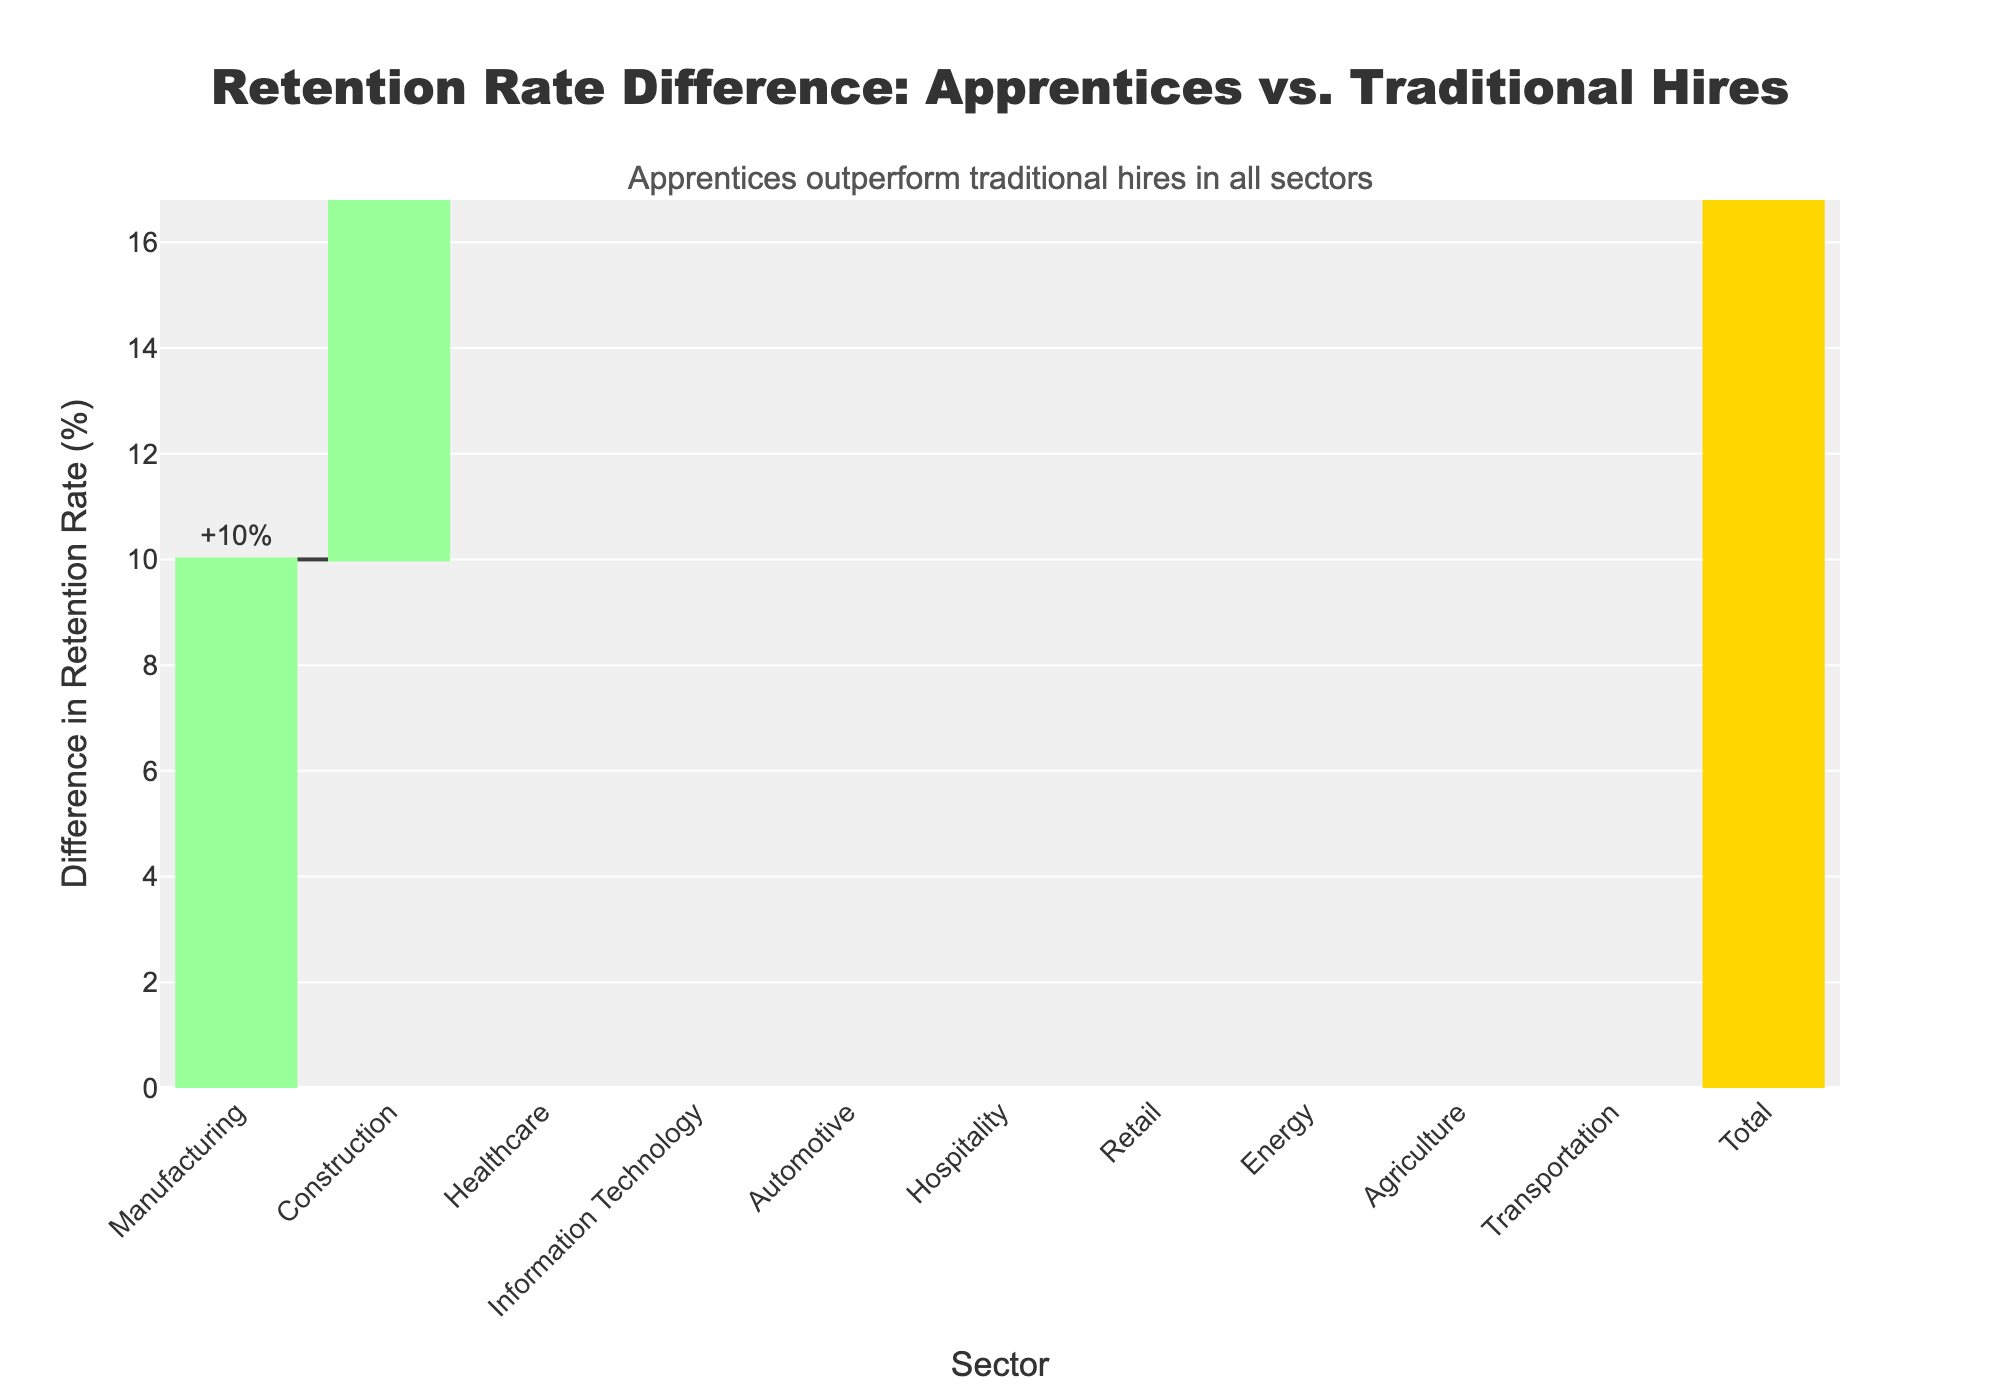What is the title of the waterfall chart? The title is displayed at the top of the chart and reads "Retention Rate Difference: Apprentices vs. Traditional Hires".
Answer: "Retention Rate Difference: Apprentices vs. Traditional Hires" How many sectors are compared in the chart? The chart lists each sector along the x-axis, and there are 10 distinct sectors labeled: Manufacturing, Construction, Healthcare, Information Technology, Automotive, Hospitality, Retail, Energy, Agriculture, and Transportation.
Answer: 10 Which sector has the highest retention rate difference? The highest retention rate difference is identified by looking at the longest bar, which corresponds to the Retail sector with a difference of +14%.
Answer: Retail What is the total retention rate difference across all sectors? The waterfall chart includes a "Total" bar at the end, representing the sum of the differences from all sectors. The total retention rate difference is +114%.
Answer: +114% Which sectors have an equal difference in retention rates? Identifying sectors with identical retention rate differences involves comparing the heights of the bars. Both the Automotive and Construction sectors have a difference of +12%.
Answer: Automotive and Construction What is the difference in retention rates for the Healthcare sector? The Healthcare sector is labeled along the x-axis, and its corresponding bar shows a difference of +8%.
Answer: +8% How does the retention rate difference in the Energy sector compare to Information Technology? The bars for both sectors are compared: the Energy sector has a difference of +8%, and the Information Technology sector has +11%. Since +11% is greater than +8%, Information Technology has a higher difference.
Answer: Information Technology has a higher difference Which sector shows a retention rate difference of less than 10%? We look for bars whose text labels indicate less than +10%. The sectors with a retention rate difference below +10% are Healthcare (+8%) and Energy (+8%).
Answer: Healthcare and Energy What is the increase in retention rates for apprentices in the Transportation sector? For the Transportation sector, the bar shows a difference of +13%, which means the retention rate for apprentices is 13% higher compared to traditional hires.
Answer: +13% Does the Agriculture sector have a higher or lower retention rate difference compared to the Manufacturing sector? Comparing the two sectors, the Agriculture sector has a difference of +12%, while the Manufacturing sector has +10%. Since +12% is higher than +10%, Agriculture has a higher difference.
Answer: Agriculture has a higher difference 